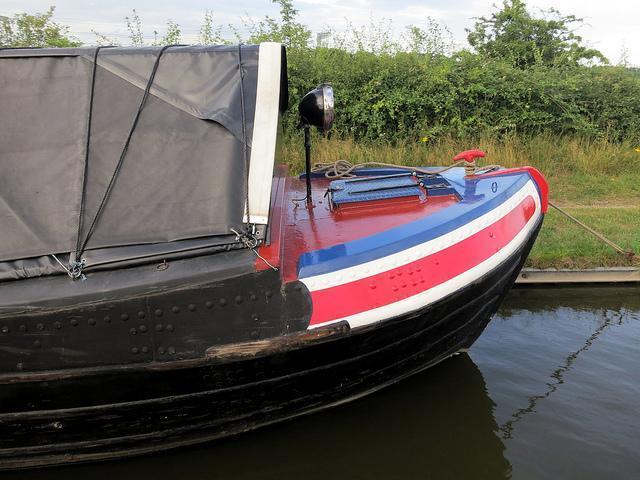How many people are in the room?
Give a very brief answer. 0. 